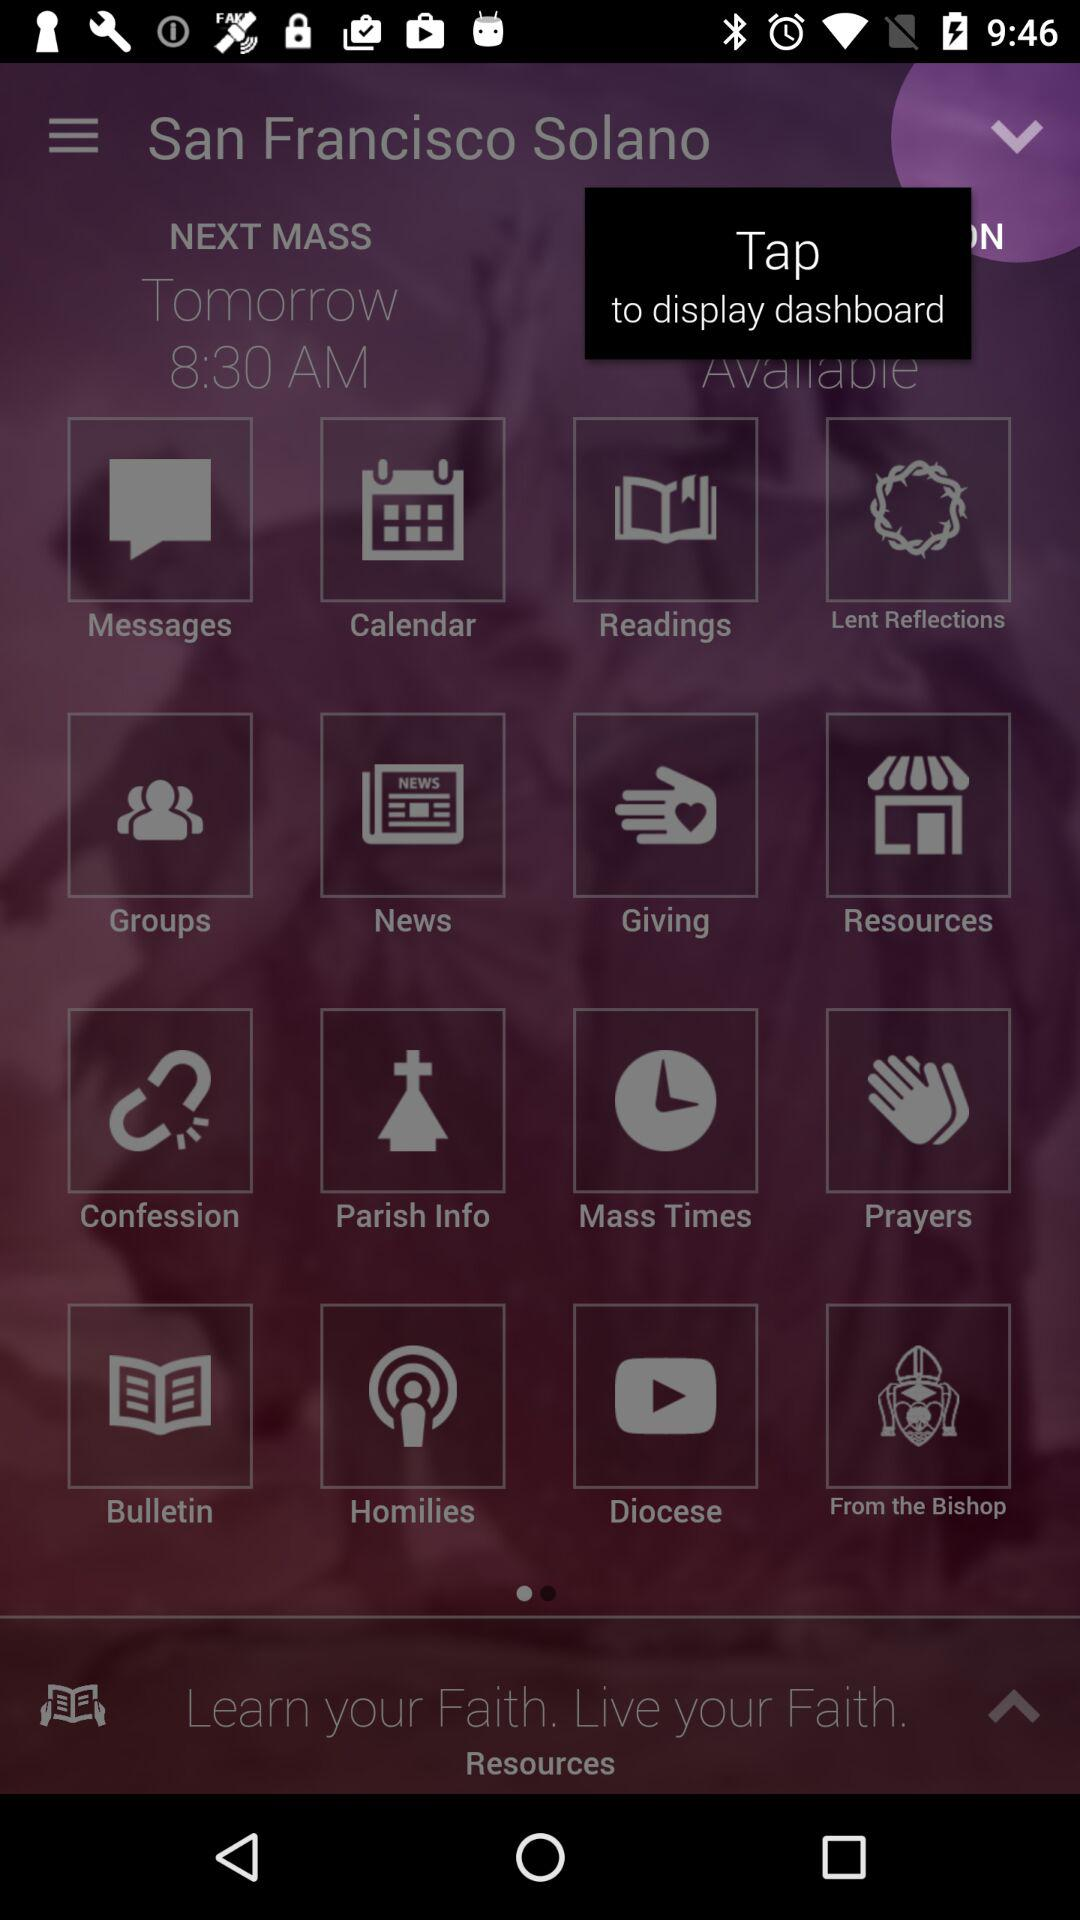What is the given location? The given location is San Francisco Solano. 